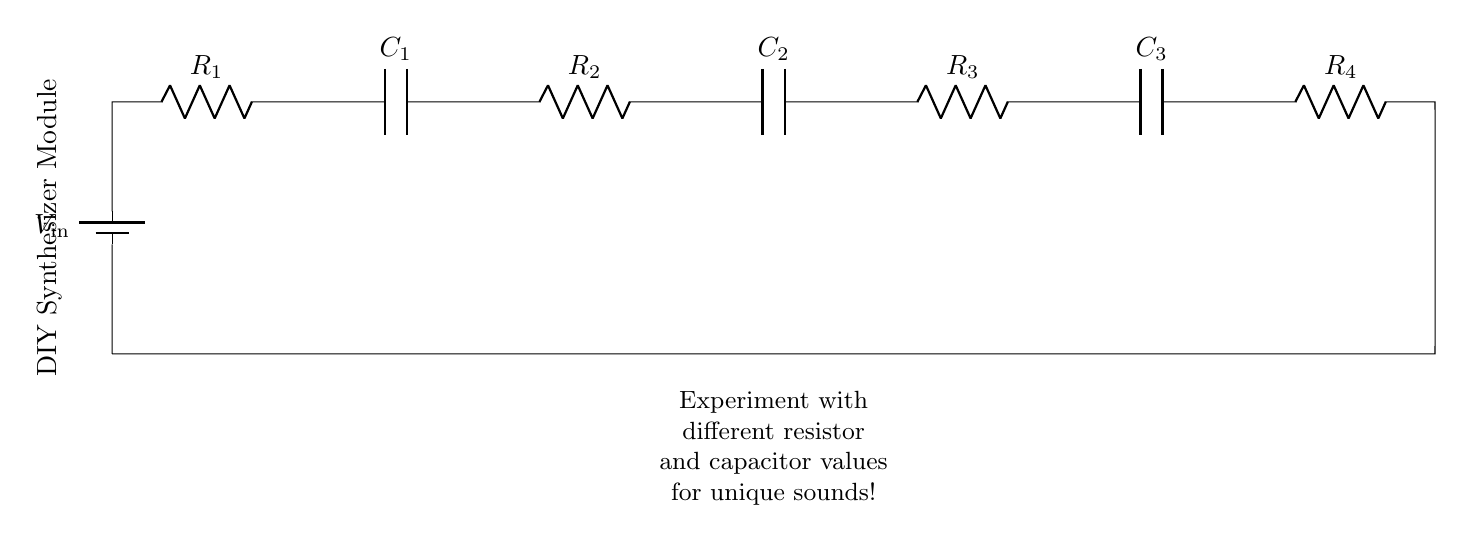What is the total number of resistors in this circuit? The circuit shows four resistors labeled R1, R2, R3, and R4 connected in series from the input to the ground. By counting, we find that there are four resistors.
Answer: 4 What is the total number of capacitors in the circuit? The circuit diagram indicates three capacitors labeled C1, C2, and C3 connected in series with the resistors. Counting them gives a total of three capacitors.
Answer: 3 What is the function of the battery in the circuit? The battery, labeled V_in, acts as the power source for the entire circuit, providing the necessary voltage to drive current through the resistors and capacitors. Its role is essential for the circuit to operate and affect sound synthesis.
Answer: Power source How would increasing R1 affect the overall circuit? Increasing R1 would raise the total resistance in the series circuit, resulting in a reduction of current flow based on Ohm’s Law (V = IR). A lower current generally means that the voltage across the capacitors would also drop, potentially affecting the sound produced by the synthesizer module.
Answer: Decreases current What is the role of the capacitors in this circuit? Capacitors in series with resistors create a time-constant circuit that can be used for filtering or shaping audio signals. They charge and discharge through the resistors, affecting the sound dynamics and tone in a synthesizer.
Answer: Filter audio signals If R2 is decreased, what happens to the voltage across C2? Decreasing R2 lowers the overall resistance in the circuit, allowing more current to flow. This increase in current can lead to a higher voltage across C2, depending on the other elements in the circuit and the time constant of the charging process. Hence, the voltage across C2 may increase until a new steady state is reached.
Answer: Increases voltage across C2 